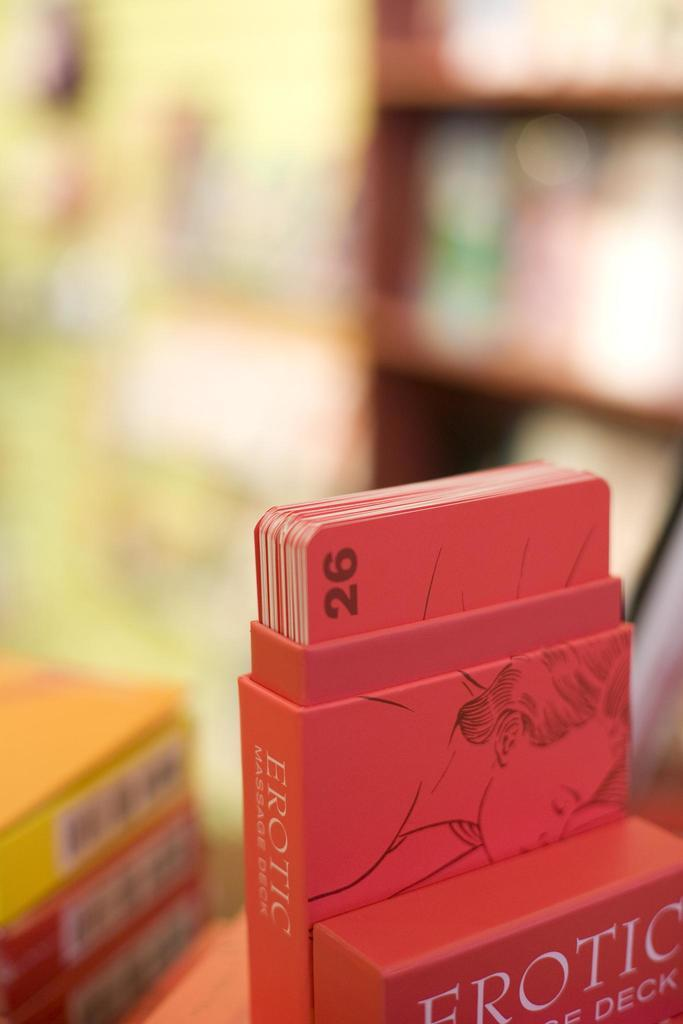Provide a one-sentence caption for the provided image. A deck of Erotic cards is displayed in an open box on a table. 